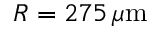<formula> <loc_0><loc_0><loc_500><loc_500>R = 2 7 5 \, \mu m</formula> 